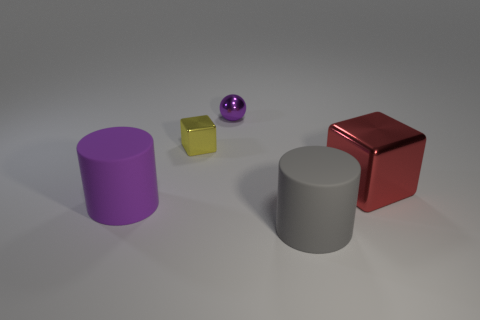Add 3 tiny red rubber balls. How many objects exist? 8 Subtract all balls. How many objects are left? 4 Subtract all red rubber cubes. Subtract all big metallic things. How many objects are left? 4 Add 3 big cylinders. How many big cylinders are left? 5 Add 2 large cyan rubber objects. How many large cyan rubber objects exist? 2 Subtract 0 green cylinders. How many objects are left? 5 